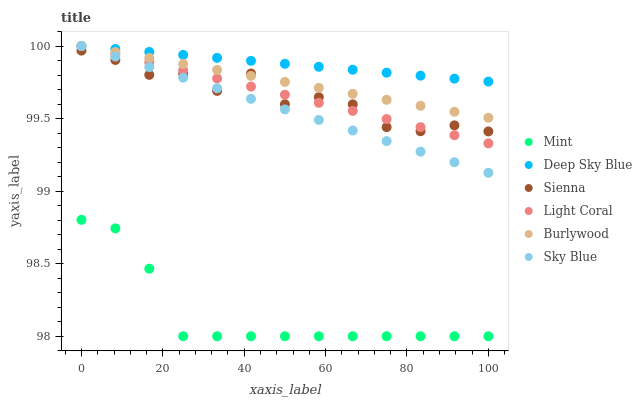Does Mint have the minimum area under the curve?
Answer yes or no. Yes. Does Deep Sky Blue have the maximum area under the curve?
Answer yes or no. Yes. Does Burlywood have the minimum area under the curve?
Answer yes or no. No. Does Burlywood have the maximum area under the curve?
Answer yes or no. No. Is Sky Blue the smoothest?
Answer yes or no. Yes. Is Sienna the roughest?
Answer yes or no. Yes. Is Burlywood the smoothest?
Answer yes or no. No. Is Burlywood the roughest?
Answer yes or no. No. Does Mint have the lowest value?
Answer yes or no. Yes. Does Burlywood have the lowest value?
Answer yes or no. No. Does Sky Blue have the highest value?
Answer yes or no. Yes. Does Sienna have the highest value?
Answer yes or no. No. Is Sienna less than Deep Sky Blue?
Answer yes or no. Yes. Is Burlywood greater than Mint?
Answer yes or no. Yes. Does Deep Sky Blue intersect Burlywood?
Answer yes or no. Yes. Is Deep Sky Blue less than Burlywood?
Answer yes or no. No. Is Deep Sky Blue greater than Burlywood?
Answer yes or no. No. Does Sienna intersect Deep Sky Blue?
Answer yes or no. No. 